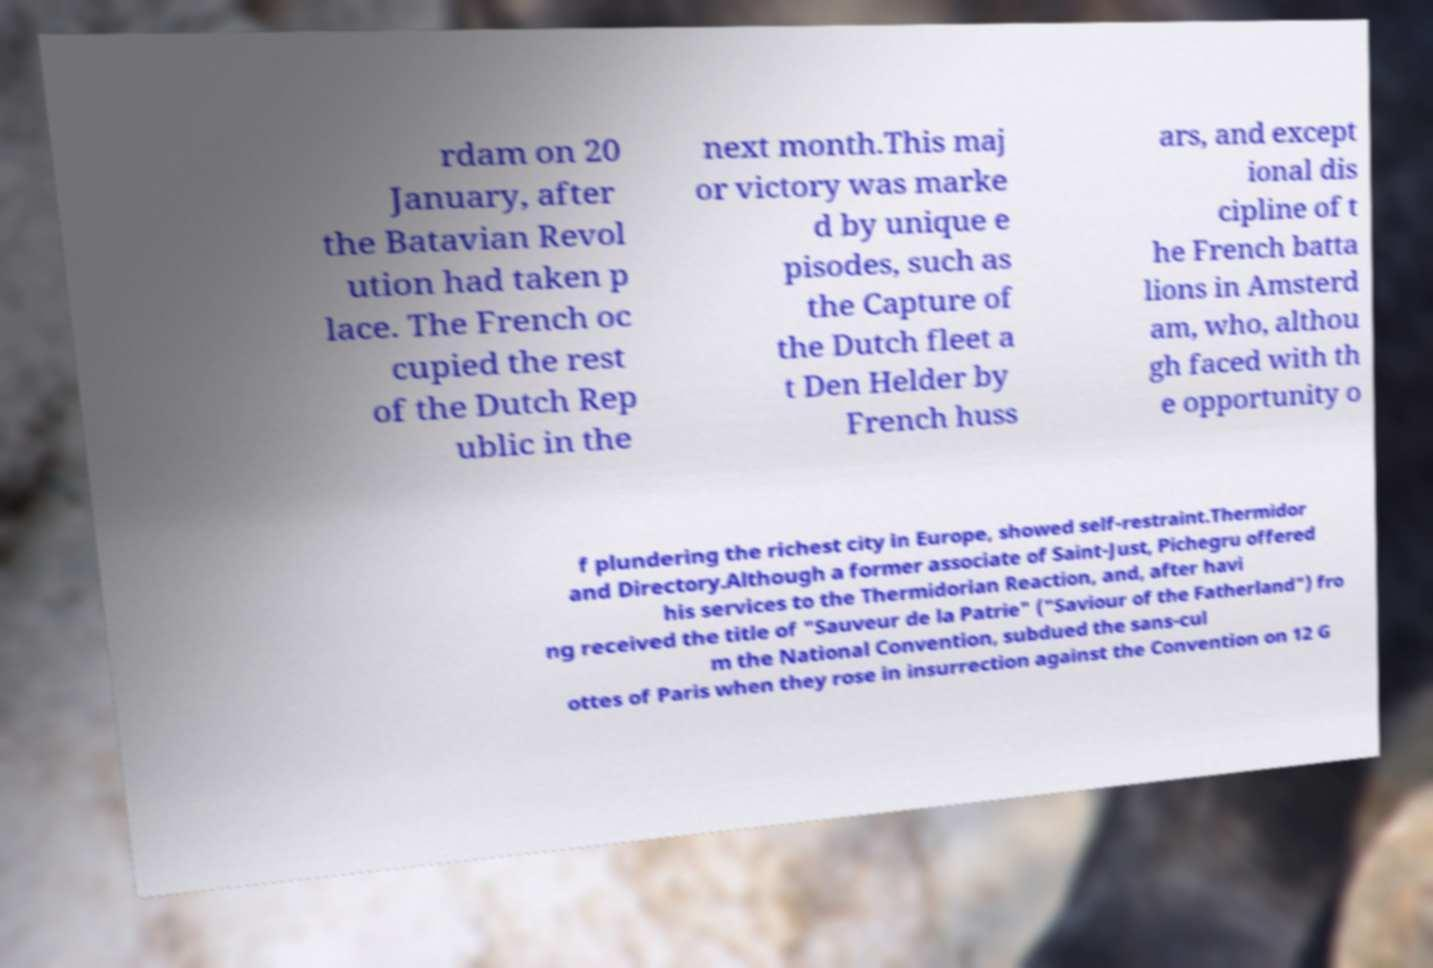What messages or text are displayed in this image? I need them in a readable, typed format. rdam on 20 January, after the Batavian Revol ution had taken p lace. The French oc cupied the rest of the Dutch Rep ublic in the next month.This maj or victory was marke d by unique e pisodes, such as the Capture of the Dutch fleet a t Den Helder by French huss ars, and except ional dis cipline of t he French batta lions in Amsterd am, who, althou gh faced with th e opportunity o f plundering the richest city in Europe, showed self-restraint.Thermidor and Directory.Although a former associate of Saint-Just, Pichegru offered his services to the Thermidorian Reaction, and, after havi ng received the title of "Sauveur de la Patrie" ("Saviour of the Fatherland") fro m the National Convention, subdued the sans-cul ottes of Paris when they rose in insurrection against the Convention on 12 G 